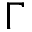Convert formula to latex. <formula><loc_0><loc_0><loc_500><loc_500>\Gamma</formula> 